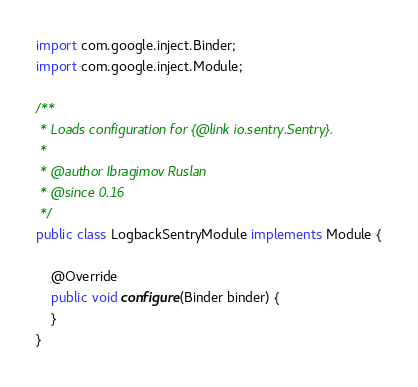Convert code to text. <code><loc_0><loc_0><loc_500><loc_500><_Java_>
import com.google.inject.Binder;
import com.google.inject.Module;

/**
 * Loads configuration for {@link io.sentry.Sentry}.
 *
 * @author Ibragimov Ruslan
 * @since 0.16
 */
public class LogbackSentryModule implements Module {

    @Override
    public void configure(Binder binder) {
    }
}
</code> 